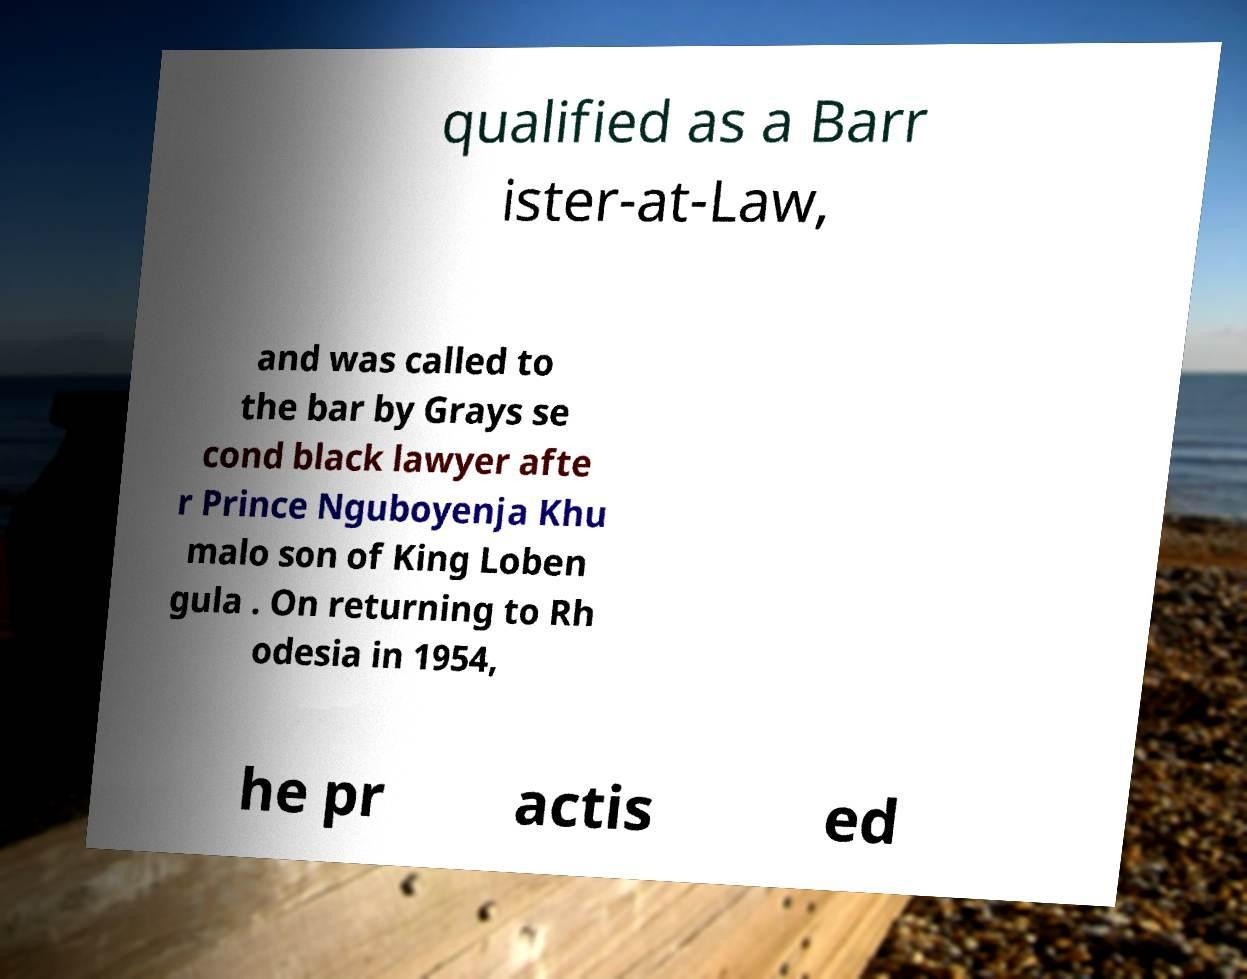Could you extract and type out the text from this image? qualified as a Barr ister-at-Law, and was called to the bar by Grays se cond black lawyer afte r Prince Nguboyenja Khu malo son of King Loben gula . On returning to Rh odesia in 1954, he pr actis ed 